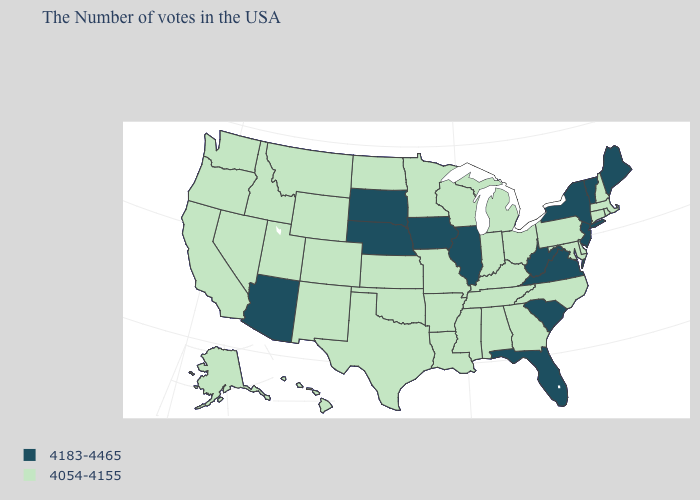Which states have the lowest value in the Northeast?
Concise answer only. Massachusetts, Rhode Island, New Hampshire, Connecticut, Pennsylvania. Among the states that border California , which have the lowest value?
Short answer required. Nevada, Oregon. What is the value of Massachusetts?
Answer briefly. 4054-4155. What is the value of Florida?
Answer briefly. 4183-4465. Which states hav the highest value in the Northeast?
Give a very brief answer. Maine, Vermont, New York, New Jersey. Is the legend a continuous bar?
Write a very short answer. No. Does the map have missing data?
Short answer required. No. What is the value of Vermont?
Quick response, please. 4183-4465. Is the legend a continuous bar?
Write a very short answer. No. Name the states that have a value in the range 4183-4465?
Write a very short answer. Maine, Vermont, New York, New Jersey, Virginia, South Carolina, West Virginia, Florida, Illinois, Iowa, Nebraska, South Dakota, Arizona. Does the first symbol in the legend represent the smallest category?
Quick response, please. No. Among the states that border Alabama , which have the highest value?
Give a very brief answer. Florida. Among the states that border Washington , which have the lowest value?
Quick response, please. Idaho, Oregon. Which states have the highest value in the USA?
Keep it brief. Maine, Vermont, New York, New Jersey, Virginia, South Carolina, West Virginia, Florida, Illinois, Iowa, Nebraska, South Dakota, Arizona. 